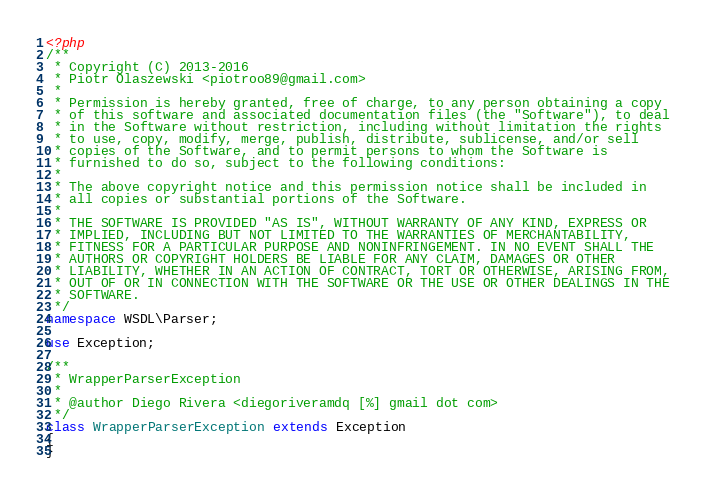<code> <loc_0><loc_0><loc_500><loc_500><_PHP_><?php
/**
 * Copyright (C) 2013-2016
 * Piotr Olaszewski <piotroo89@gmail.com>
 *
 * Permission is hereby granted, free of charge, to any person obtaining a copy
 * of this software and associated documentation files (the "Software"), to deal
 * in the Software without restriction, including without limitation the rights
 * to use, copy, modify, merge, publish, distribute, sublicense, and/or sell
 * copies of the Software, and to permit persons to whom the Software is
 * furnished to do so, subject to the following conditions:
 *
 * The above copyright notice and this permission notice shall be included in
 * all copies or substantial portions of the Software.
 *
 * THE SOFTWARE IS PROVIDED "AS IS", WITHOUT WARRANTY OF ANY KIND, EXPRESS OR
 * IMPLIED, INCLUDING BUT NOT LIMITED TO THE WARRANTIES OF MERCHANTABILITY,
 * FITNESS FOR A PARTICULAR PURPOSE AND NONINFRINGEMENT. IN NO EVENT SHALL THE
 * AUTHORS OR COPYRIGHT HOLDERS BE LIABLE FOR ANY CLAIM, DAMAGES OR OTHER
 * LIABILITY, WHETHER IN AN ACTION OF CONTRACT, TORT OR OTHERWISE, ARISING FROM,
 * OUT OF OR IN CONNECTION WITH THE SOFTWARE OR THE USE OR OTHER DEALINGS IN THE
 * SOFTWARE.
 */
namespace WSDL\Parser;

use Exception;

/**
 * WrapperParserException
 *
 * @author Diego Rivera <diegoriveramdq [%] gmail dot com>
 */
class WrapperParserException extends Exception
{
}
</code> 